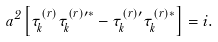Convert formula to latex. <formula><loc_0><loc_0><loc_500><loc_500>a ^ { 2 } \left [ \tau _ { k } ^ { ( r ) } \tau _ { k } ^ { ( r ) \prime * } - \tau _ { k } ^ { ( r ) \prime } \tau _ { k } ^ { ( r ) * } \right ] = i .</formula> 